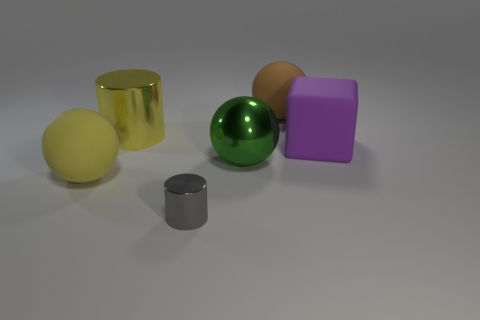Add 3 yellow metal cylinders. How many objects exist? 9 Subtract all blocks. How many objects are left? 5 Subtract 1 yellow cylinders. How many objects are left? 5 Subtract all small green shiny spheres. Subtract all big brown rubber spheres. How many objects are left? 5 Add 4 large yellow metal cylinders. How many large yellow metal cylinders are left? 5 Add 5 yellow metal objects. How many yellow metal objects exist? 6 